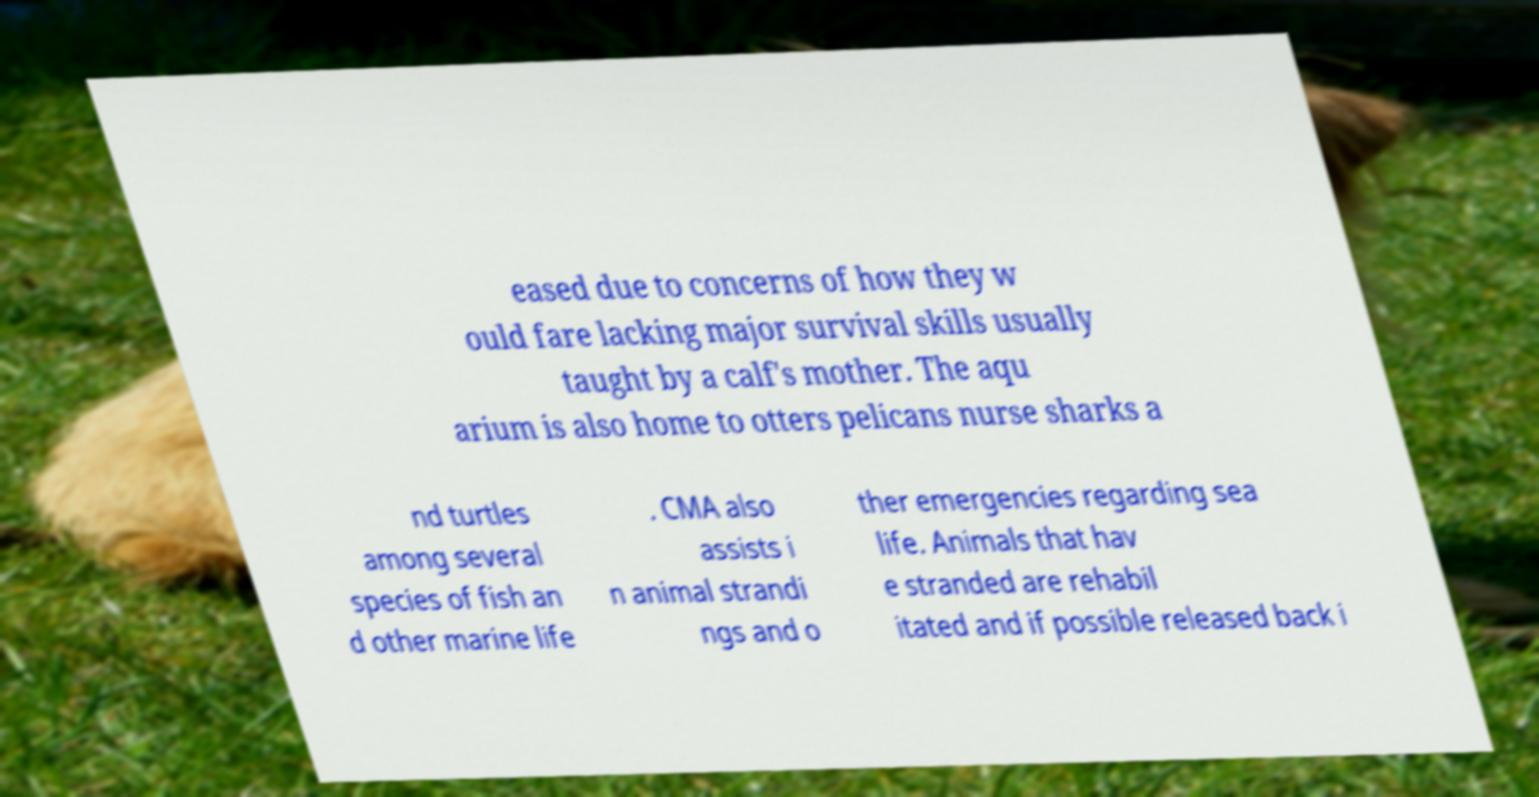There's text embedded in this image that I need extracted. Can you transcribe it verbatim? eased due to concerns of how they w ould fare lacking major survival skills usually taught by a calf's mother. The aqu arium is also home to otters pelicans nurse sharks a nd turtles among several species of fish an d other marine life . CMA also assists i n animal strandi ngs and o ther emergencies regarding sea life. Animals that hav e stranded are rehabil itated and if possible released back i 